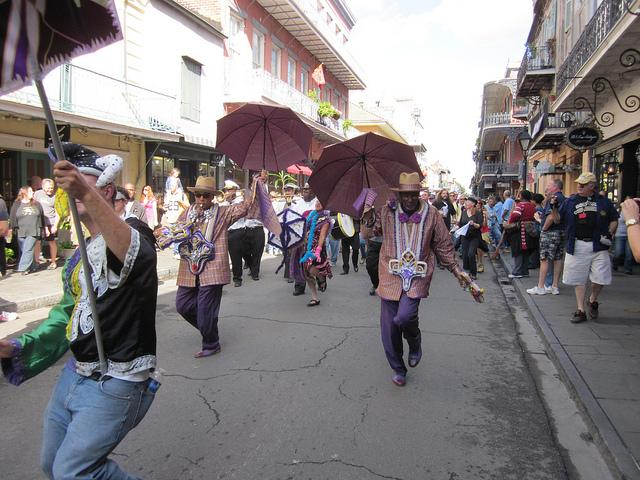What activity are people holding umbrellas taking part in? parade 